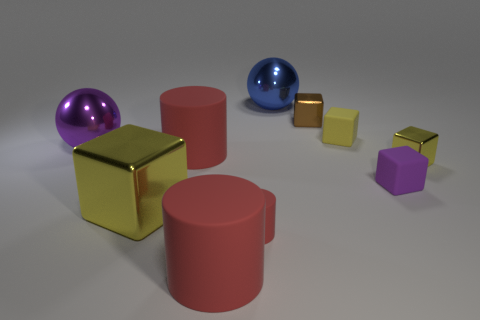Subtract all yellow cubes. How many were subtracted if there are1yellow cubes left? 2 Subtract all small metallic cubes. How many cubes are left? 3 Subtract all purple cylinders. How many yellow cubes are left? 3 Subtract all yellow blocks. How many blocks are left? 2 Subtract all cylinders. How many objects are left? 7 Add 8 tiny gray spheres. How many tiny gray spheres exist? 8 Subtract 0 green balls. How many objects are left? 10 Subtract 2 spheres. How many spheres are left? 0 Subtract all brown cylinders. Subtract all purple blocks. How many cylinders are left? 3 Subtract all small purple rubber things. Subtract all red matte cylinders. How many objects are left? 6 